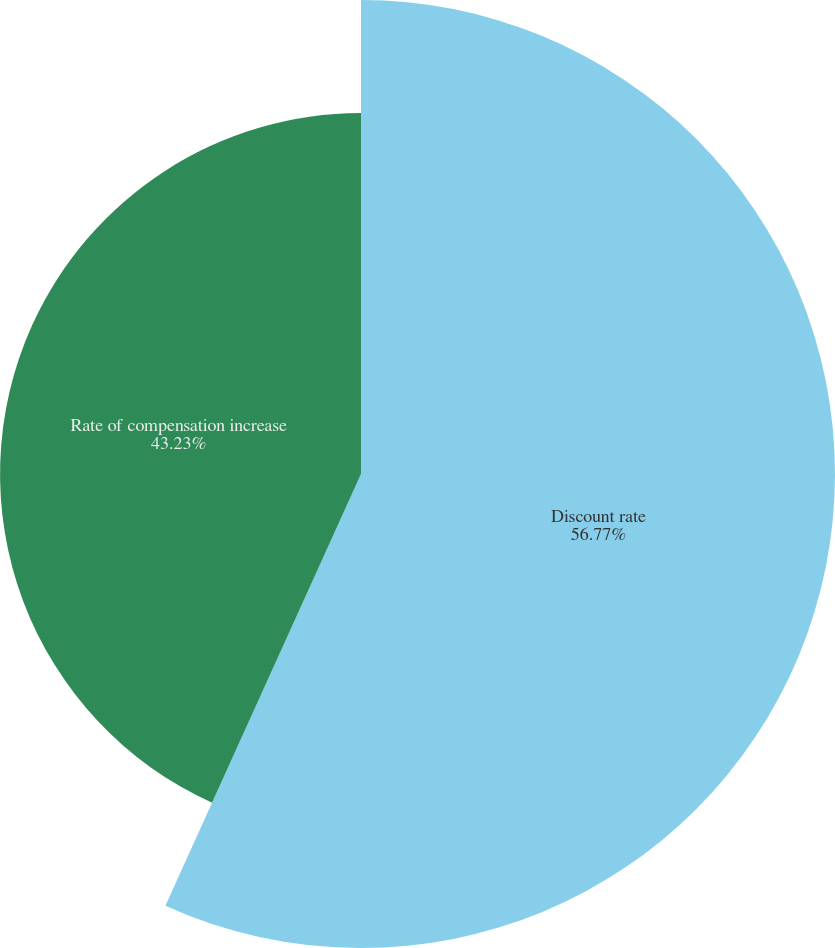Convert chart to OTSL. <chart><loc_0><loc_0><loc_500><loc_500><pie_chart><fcel>Discount rate<fcel>Rate of compensation increase<nl><fcel>56.77%<fcel>43.23%<nl></chart> 